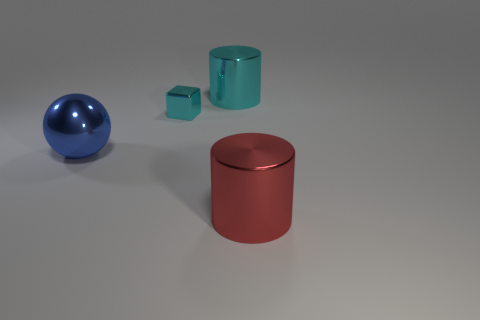What color is the metal cylinder behind the big shiny thing that is on the right side of the cyan cylinder that is to the left of the big red shiny thing?
Ensure brevity in your answer.  Cyan. What number of other objects are there of the same color as the shiny sphere?
Provide a succinct answer. 0. Are there fewer tiny blocks than yellow metallic cubes?
Your response must be concise. No. The thing that is in front of the tiny cyan block and on the right side of the cyan shiny block is what color?
Keep it short and to the point. Red. There is another big object that is the same shape as the big red metal object; what is it made of?
Give a very brief answer. Metal. Is there anything else that has the same size as the block?
Your answer should be compact. No. Is the number of big metallic balls greater than the number of metal objects?
Provide a succinct answer. No. There is a metal thing that is on the right side of the big ball and in front of the cyan metallic block; what is its size?
Provide a succinct answer. Large. The blue metallic object has what shape?
Ensure brevity in your answer.  Sphere. What number of big red shiny objects have the same shape as the big cyan shiny thing?
Keep it short and to the point. 1. 